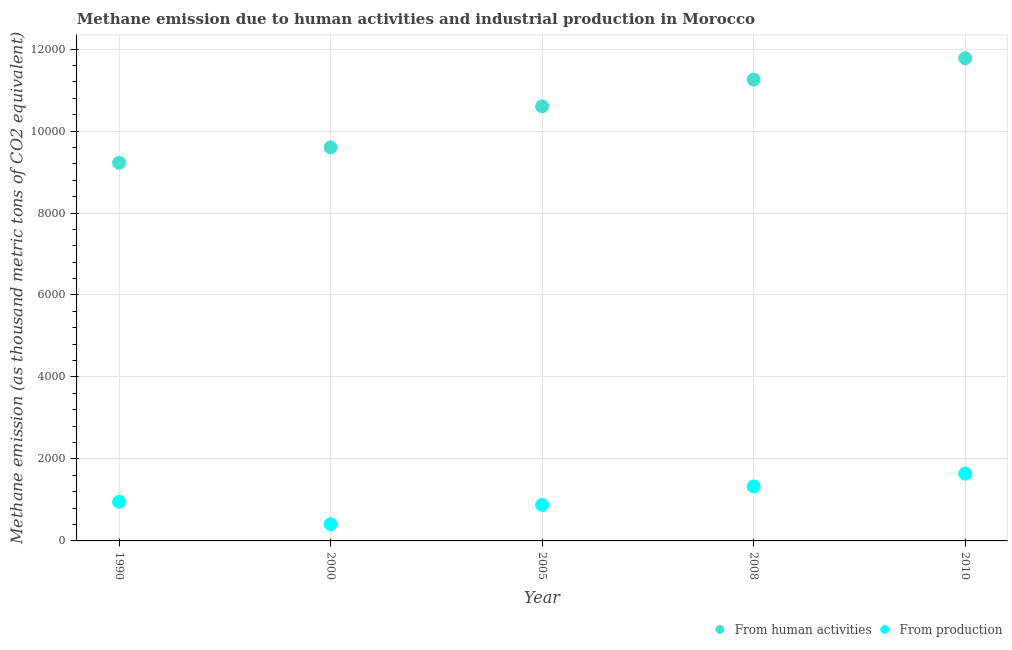How many different coloured dotlines are there?
Keep it short and to the point. 2. Is the number of dotlines equal to the number of legend labels?
Your answer should be compact. Yes. What is the amount of emissions from human activities in 2000?
Your answer should be very brief. 9601.5. Across all years, what is the maximum amount of emissions generated from industries?
Provide a short and direct response. 1641.9. Across all years, what is the minimum amount of emissions from human activities?
Offer a terse response. 9225.5. What is the total amount of emissions generated from industries in the graph?
Provide a succinct answer. 5211.3. What is the difference between the amount of emissions generated from industries in 1990 and that in 2000?
Offer a terse response. 547.8. What is the difference between the amount of emissions from human activities in 1990 and the amount of emissions generated from industries in 2008?
Provide a succinct answer. 7896.8. What is the average amount of emissions generated from industries per year?
Offer a terse response. 1042.26. In the year 2008, what is the difference between the amount of emissions generated from industries and amount of emissions from human activities?
Keep it short and to the point. -9926.4. What is the ratio of the amount of emissions from human activities in 2000 to that in 2010?
Your answer should be compact. 0.82. Is the amount of emissions from human activities in 2000 less than that in 2010?
Provide a short and direct response. Yes. Is the difference between the amount of emissions from human activities in 1990 and 2005 greater than the difference between the amount of emissions generated from industries in 1990 and 2005?
Provide a short and direct response. No. What is the difference between the highest and the second highest amount of emissions generated from industries?
Keep it short and to the point. 313.2. What is the difference between the highest and the lowest amount of emissions from human activities?
Keep it short and to the point. 2552.1. In how many years, is the amount of emissions from human activities greater than the average amount of emissions from human activities taken over all years?
Offer a very short reply. 3. Is the sum of the amount of emissions from human activities in 2005 and 2010 greater than the maximum amount of emissions generated from industries across all years?
Provide a succinct answer. Yes. Does the amount of emissions generated from industries monotonically increase over the years?
Give a very brief answer. No. Is the amount of emissions generated from industries strictly less than the amount of emissions from human activities over the years?
Give a very brief answer. Yes. What is the difference between two consecutive major ticks on the Y-axis?
Provide a short and direct response. 2000. Does the graph contain any zero values?
Your answer should be very brief. No. What is the title of the graph?
Give a very brief answer. Methane emission due to human activities and industrial production in Morocco. Does "Primary school" appear as one of the legend labels in the graph?
Your response must be concise. No. What is the label or title of the X-axis?
Your answer should be compact. Year. What is the label or title of the Y-axis?
Your response must be concise. Methane emission (as thousand metric tons of CO2 equivalent). What is the Methane emission (as thousand metric tons of CO2 equivalent) of From human activities in 1990?
Provide a short and direct response. 9225.5. What is the Methane emission (as thousand metric tons of CO2 equivalent) in From production in 1990?
Offer a terse response. 955.4. What is the Methane emission (as thousand metric tons of CO2 equivalent) of From human activities in 2000?
Ensure brevity in your answer.  9601.5. What is the Methane emission (as thousand metric tons of CO2 equivalent) of From production in 2000?
Offer a very short reply. 407.6. What is the Methane emission (as thousand metric tons of CO2 equivalent) of From human activities in 2005?
Make the answer very short. 1.06e+04. What is the Methane emission (as thousand metric tons of CO2 equivalent) in From production in 2005?
Offer a terse response. 877.7. What is the Methane emission (as thousand metric tons of CO2 equivalent) in From human activities in 2008?
Your response must be concise. 1.13e+04. What is the Methane emission (as thousand metric tons of CO2 equivalent) of From production in 2008?
Ensure brevity in your answer.  1328.7. What is the Methane emission (as thousand metric tons of CO2 equivalent) of From human activities in 2010?
Your answer should be very brief. 1.18e+04. What is the Methane emission (as thousand metric tons of CO2 equivalent) in From production in 2010?
Keep it short and to the point. 1641.9. Across all years, what is the maximum Methane emission (as thousand metric tons of CO2 equivalent) of From human activities?
Offer a terse response. 1.18e+04. Across all years, what is the maximum Methane emission (as thousand metric tons of CO2 equivalent) of From production?
Make the answer very short. 1641.9. Across all years, what is the minimum Methane emission (as thousand metric tons of CO2 equivalent) of From human activities?
Your response must be concise. 9225.5. Across all years, what is the minimum Methane emission (as thousand metric tons of CO2 equivalent) of From production?
Make the answer very short. 407.6. What is the total Methane emission (as thousand metric tons of CO2 equivalent) in From human activities in the graph?
Offer a terse response. 5.25e+04. What is the total Methane emission (as thousand metric tons of CO2 equivalent) of From production in the graph?
Your response must be concise. 5211.3. What is the difference between the Methane emission (as thousand metric tons of CO2 equivalent) in From human activities in 1990 and that in 2000?
Make the answer very short. -376. What is the difference between the Methane emission (as thousand metric tons of CO2 equivalent) in From production in 1990 and that in 2000?
Offer a terse response. 547.8. What is the difference between the Methane emission (as thousand metric tons of CO2 equivalent) of From human activities in 1990 and that in 2005?
Keep it short and to the point. -1377.4. What is the difference between the Methane emission (as thousand metric tons of CO2 equivalent) of From production in 1990 and that in 2005?
Offer a very short reply. 77.7. What is the difference between the Methane emission (as thousand metric tons of CO2 equivalent) in From human activities in 1990 and that in 2008?
Make the answer very short. -2029.6. What is the difference between the Methane emission (as thousand metric tons of CO2 equivalent) in From production in 1990 and that in 2008?
Offer a very short reply. -373.3. What is the difference between the Methane emission (as thousand metric tons of CO2 equivalent) of From human activities in 1990 and that in 2010?
Ensure brevity in your answer.  -2552.1. What is the difference between the Methane emission (as thousand metric tons of CO2 equivalent) of From production in 1990 and that in 2010?
Give a very brief answer. -686.5. What is the difference between the Methane emission (as thousand metric tons of CO2 equivalent) in From human activities in 2000 and that in 2005?
Provide a short and direct response. -1001.4. What is the difference between the Methane emission (as thousand metric tons of CO2 equivalent) in From production in 2000 and that in 2005?
Keep it short and to the point. -470.1. What is the difference between the Methane emission (as thousand metric tons of CO2 equivalent) of From human activities in 2000 and that in 2008?
Ensure brevity in your answer.  -1653.6. What is the difference between the Methane emission (as thousand metric tons of CO2 equivalent) of From production in 2000 and that in 2008?
Provide a succinct answer. -921.1. What is the difference between the Methane emission (as thousand metric tons of CO2 equivalent) in From human activities in 2000 and that in 2010?
Keep it short and to the point. -2176.1. What is the difference between the Methane emission (as thousand metric tons of CO2 equivalent) of From production in 2000 and that in 2010?
Provide a short and direct response. -1234.3. What is the difference between the Methane emission (as thousand metric tons of CO2 equivalent) in From human activities in 2005 and that in 2008?
Keep it short and to the point. -652.2. What is the difference between the Methane emission (as thousand metric tons of CO2 equivalent) of From production in 2005 and that in 2008?
Make the answer very short. -451. What is the difference between the Methane emission (as thousand metric tons of CO2 equivalent) in From human activities in 2005 and that in 2010?
Ensure brevity in your answer.  -1174.7. What is the difference between the Methane emission (as thousand metric tons of CO2 equivalent) of From production in 2005 and that in 2010?
Provide a succinct answer. -764.2. What is the difference between the Methane emission (as thousand metric tons of CO2 equivalent) in From human activities in 2008 and that in 2010?
Provide a succinct answer. -522.5. What is the difference between the Methane emission (as thousand metric tons of CO2 equivalent) of From production in 2008 and that in 2010?
Your answer should be compact. -313.2. What is the difference between the Methane emission (as thousand metric tons of CO2 equivalent) in From human activities in 1990 and the Methane emission (as thousand metric tons of CO2 equivalent) in From production in 2000?
Offer a terse response. 8817.9. What is the difference between the Methane emission (as thousand metric tons of CO2 equivalent) in From human activities in 1990 and the Methane emission (as thousand metric tons of CO2 equivalent) in From production in 2005?
Provide a short and direct response. 8347.8. What is the difference between the Methane emission (as thousand metric tons of CO2 equivalent) of From human activities in 1990 and the Methane emission (as thousand metric tons of CO2 equivalent) of From production in 2008?
Give a very brief answer. 7896.8. What is the difference between the Methane emission (as thousand metric tons of CO2 equivalent) in From human activities in 1990 and the Methane emission (as thousand metric tons of CO2 equivalent) in From production in 2010?
Keep it short and to the point. 7583.6. What is the difference between the Methane emission (as thousand metric tons of CO2 equivalent) of From human activities in 2000 and the Methane emission (as thousand metric tons of CO2 equivalent) of From production in 2005?
Offer a terse response. 8723.8. What is the difference between the Methane emission (as thousand metric tons of CO2 equivalent) in From human activities in 2000 and the Methane emission (as thousand metric tons of CO2 equivalent) in From production in 2008?
Keep it short and to the point. 8272.8. What is the difference between the Methane emission (as thousand metric tons of CO2 equivalent) of From human activities in 2000 and the Methane emission (as thousand metric tons of CO2 equivalent) of From production in 2010?
Make the answer very short. 7959.6. What is the difference between the Methane emission (as thousand metric tons of CO2 equivalent) of From human activities in 2005 and the Methane emission (as thousand metric tons of CO2 equivalent) of From production in 2008?
Keep it short and to the point. 9274.2. What is the difference between the Methane emission (as thousand metric tons of CO2 equivalent) of From human activities in 2005 and the Methane emission (as thousand metric tons of CO2 equivalent) of From production in 2010?
Offer a very short reply. 8961. What is the difference between the Methane emission (as thousand metric tons of CO2 equivalent) of From human activities in 2008 and the Methane emission (as thousand metric tons of CO2 equivalent) of From production in 2010?
Your response must be concise. 9613.2. What is the average Methane emission (as thousand metric tons of CO2 equivalent) in From human activities per year?
Give a very brief answer. 1.05e+04. What is the average Methane emission (as thousand metric tons of CO2 equivalent) in From production per year?
Give a very brief answer. 1042.26. In the year 1990, what is the difference between the Methane emission (as thousand metric tons of CO2 equivalent) in From human activities and Methane emission (as thousand metric tons of CO2 equivalent) in From production?
Offer a terse response. 8270.1. In the year 2000, what is the difference between the Methane emission (as thousand metric tons of CO2 equivalent) in From human activities and Methane emission (as thousand metric tons of CO2 equivalent) in From production?
Give a very brief answer. 9193.9. In the year 2005, what is the difference between the Methane emission (as thousand metric tons of CO2 equivalent) in From human activities and Methane emission (as thousand metric tons of CO2 equivalent) in From production?
Your answer should be very brief. 9725.2. In the year 2008, what is the difference between the Methane emission (as thousand metric tons of CO2 equivalent) in From human activities and Methane emission (as thousand metric tons of CO2 equivalent) in From production?
Your answer should be very brief. 9926.4. In the year 2010, what is the difference between the Methane emission (as thousand metric tons of CO2 equivalent) of From human activities and Methane emission (as thousand metric tons of CO2 equivalent) of From production?
Keep it short and to the point. 1.01e+04. What is the ratio of the Methane emission (as thousand metric tons of CO2 equivalent) in From human activities in 1990 to that in 2000?
Make the answer very short. 0.96. What is the ratio of the Methane emission (as thousand metric tons of CO2 equivalent) in From production in 1990 to that in 2000?
Your response must be concise. 2.34. What is the ratio of the Methane emission (as thousand metric tons of CO2 equivalent) of From human activities in 1990 to that in 2005?
Offer a very short reply. 0.87. What is the ratio of the Methane emission (as thousand metric tons of CO2 equivalent) in From production in 1990 to that in 2005?
Your response must be concise. 1.09. What is the ratio of the Methane emission (as thousand metric tons of CO2 equivalent) of From human activities in 1990 to that in 2008?
Offer a terse response. 0.82. What is the ratio of the Methane emission (as thousand metric tons of CO2 equivalent) in From production in 1990 to that in 2008?
Your response must be concise. 0.72. What is the ratio of the Methane emission (as thousand metric tons of CO2 equivalent) of From human activities in 1990 to that in 2010?
Offer a terse response. 0.78. What is the ratio of the Methane emission (as thousand metric tons of CO2 equivalent) in From production in 1990 to that in 2010?
Ensure brevity in your answer.  0.58. What is the ratio of the Methane emission (as thousand metric tons of CO2 equivalent) of From human activities in 2000 to that in 2005?
Your response must be concise. 0.91. What is the ratio of the Methane emission (as thousand metric tons of CO2 equivalent) of From production in 2000 to that in 2005?
Your answer should be very brief. 0.46. What is the ratio of the Methane emission (as thousand metric tons of CO2 equivalent) in From human activities in 2000 to that in 2008?
Provide a succinct answer. 0.85. What is the ratio of the Methane emission (as thousand metric tons of CO2 equivalent) in From production in 2000 to that in 2008?
Give a very brief answer. 0.31. What is the ratio of the Methane emission (as thousand metric tons of CO2 equivalent) in From human activities in 2000 to that in 2010?
Provide a succinct answer. 0.82. What is the ratio of the Methane emission (as thousand metric tons of CO2 equivalent) of From production in 2000 to that in 2010?
Provide a short and direct response. 0.25. What is the ratio of the Methane emission (as thousand metric tons of CO2 equivalent) in From human activities in 2005 to that in 2008?
Provide a succinct answer. 0.94. What is the ratio of the Methane emission (as thousand metric tons of CO2 equivalent) in From production in 2005 to that in 2008?
Make the answer very short. 0.66. What is the ratio of the Methane emission (as thousand metric tons of CO2 equivalent) of From human activities in 2005 to that in 2010?
Offer a terse response. 0.9. What is the ratio of the Methane emission (as thousand metric tons of CO2 equivalent) in From production in 2005 to that in 2010?
Your answer should be very brief. 0.53. What is the ratio of the Methane emission (as thousand metric tons of CO2 equivalent) in From human activities in 2008 to that in 2010?
Offer a very short reply. 0.96. What is the ratio of the Methane emission (as thousand metric tons of CO2 equivalent) in From production in 2008 to that in 2010?
Offer a very short reply. 0.81. What is the difference between the highest and the second highest Methane emission (as thousand metric tons of CO2 equivalent) of From human activities?
Your answer should be compact. 522.5. What is the difference between the highest and the second highest Methane emission (as thousand metric tons of CO2 equivalent) in From production?
Provide a short and direct response. 313.2. What is the difference between the highest and the lowest Methane emission (as thousand metric tons of CO2 equivalent) in From human activities?
Give a very brief answer. 2552.1. What is the difference between the highest and the lowest Methane emission (as thousand metric tons of CO2 equivalent) of From production?
Your answer should be very brief. 1234.3. 